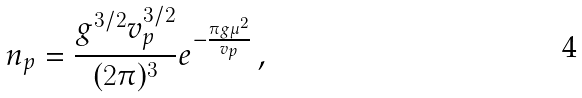Convert formula to latex. <formula><loc_0><loc_0><loc_500><loc_500>n _ { p } = \frac { g ^ { 3 / 2 } v ^ { 3 / 2 } _ { p } } { ( 2 \pi ) ^ { 3 } } e ^ { - \frac { \pi g \mu ^ { 2 } } { v _ { p } } } \, ,</formula> 